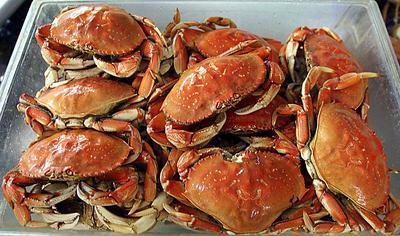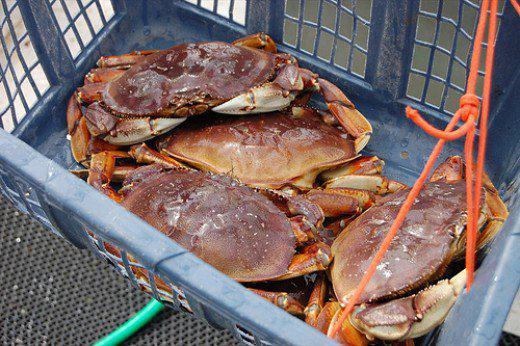The first image is the image on the left, the second image is the image on the right. Assess this claim about the two images: "At least one beverage in a clear glass is on the right of a pile of seafood with claws in one image.". Correct or not? Answer yes or no. No. The first image is the image on the left, the second image is the image on the right. Considering the images on both sides, is "The crabs in one of the images are being served with drinks." valid? Answer yes or no. No. 